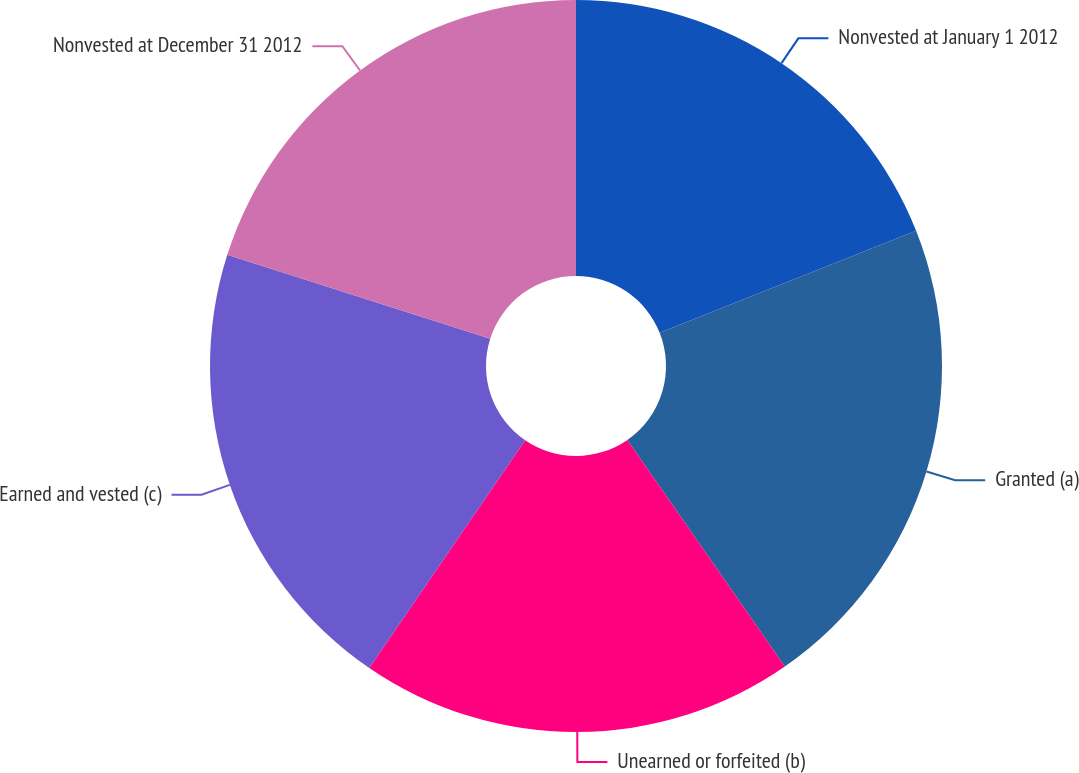Convert chart. <chart><loc_0><loc_0><loc_500><loc_500><pie_chart><fcel>Nonvested at January 1 2012<fcel>Granted (a)<fcel>Unearned or forfeited (b)<fcel>Earned and vested (c)<fcel>Nonvested at December 31 2012<nl><fcel>18.98%<fcel>21.36%<fcel>19.22%<fcel>20.36%<fcel>20.09%<nl></chart> 